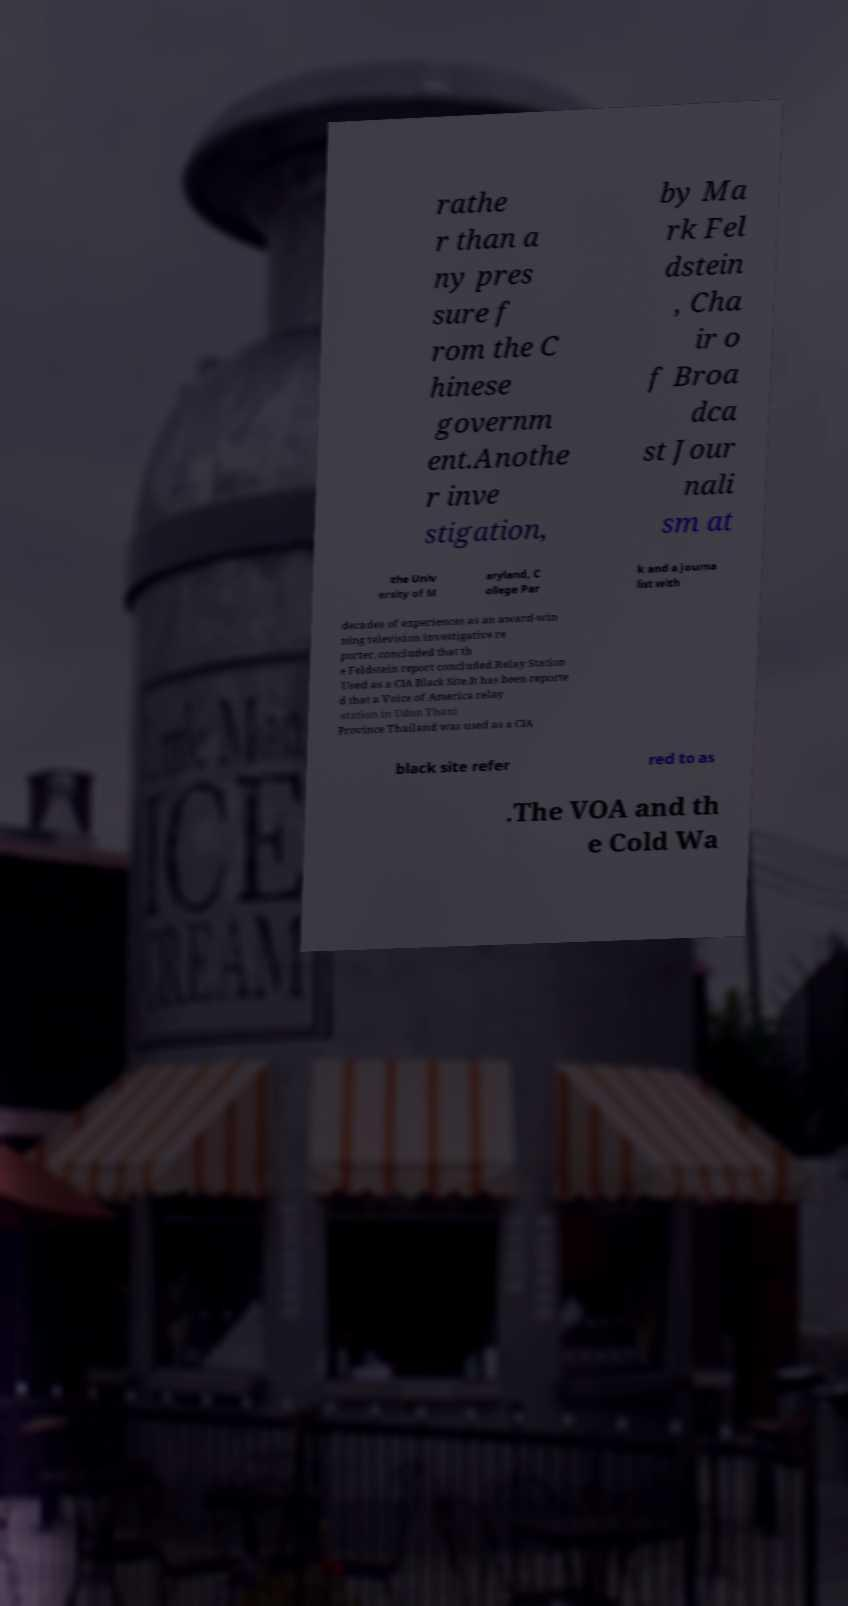Could you assist in decoding the text presented in this image and type it out clearly? rathe r than a ny pres sure f rom the C hinese governm ent.Anothe r inve stigation, by Ma rk Fel dstein , Cha ir o f Broa dca st Jour nali sm at the Univ ersity of M aryland, C ollege Par k and a journa list with decades of experiences as an award-win ning television investigative re porter, concluded that th e Feldstein report concluded.Relay Station Used as a CIA Black Site.It has been reporte d that a Voice of America relay station in Udon Thani Province Thailand was used as a CIA black site refer red to as .The VOA and th e Cold Wa 